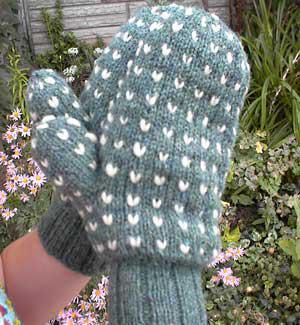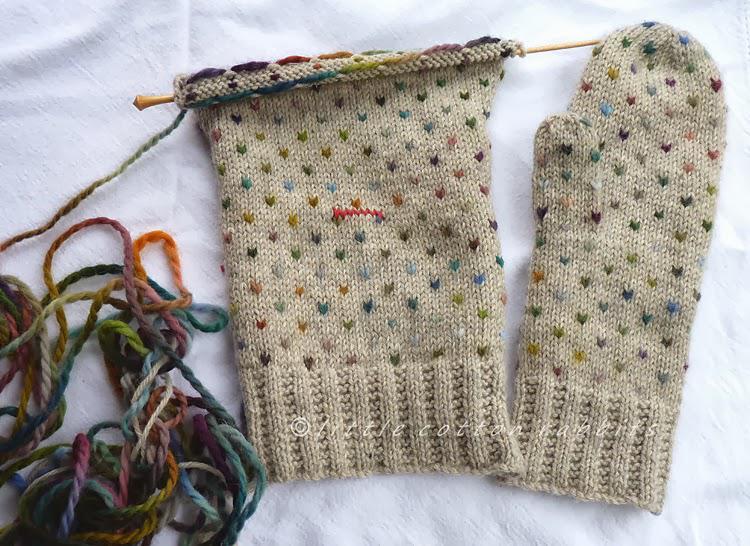The first image is the image on the left, the second image is the image on the right. For the images displayed, is the sentence "There are gloves with heart pattern shown." factually correct? Answer yes or no. Yes. The first image is the image on the left, the second image is the image on the right. Examine the images to the left and right. Is the description "The mittens in one of the images are lying on a wooden surface" accurate? Answer yes or no. No. 